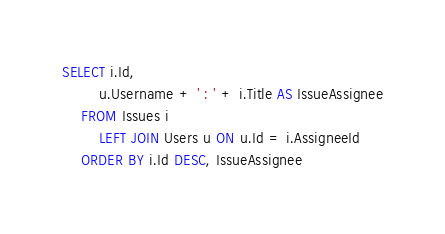Convert code to text. <code><loc_0><loc_0><loc_500><loc_500><_SQL_>SELECT i.Id,
		u.Username + ' : ' + i.Title AS IssueAssignee
	FROM Issues i
		LEFT JOIN Users u ON u.Id = i.AssigneeId
	ORDER BY i.Id DESC, IssueAssignee</code> 